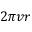Convert formula to latex. <formula><loc_0><loc_0><loc_500><loc_500>2 \pi v r</formula> 